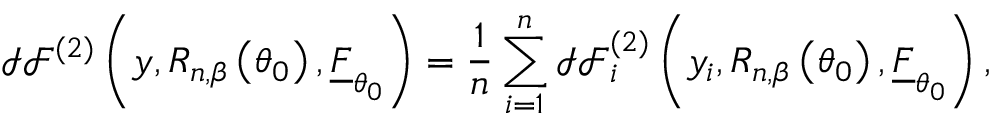<formula> <loc_0><loc_0><loc_500><loc_500>\mathcal { I F } ^ { ( 2 ) } \left ( y , R _ { n , \beta } \left ( \theta _ { 0 } \right ) , \underline { F } _ { \theta _ { 0 } } \right ) = \frac { 1 } { n } \sum _ { i = 1 } ^ { n } \mathcal { I F } _ { i } ^ { ( 2 ) } \left ( y _ { i } , R _ { n , \beta } \left ( \theta _ { 0 } \right ) , \underline { F } _ { \theta _ { 0 } } \right ) ,</formula> 